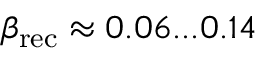<formula> <loc_0><loc_0><loc_500><loc_500>\beta _ { r e c } \approx 0 . 0 6 \dots 0 . 1 4</formula> 